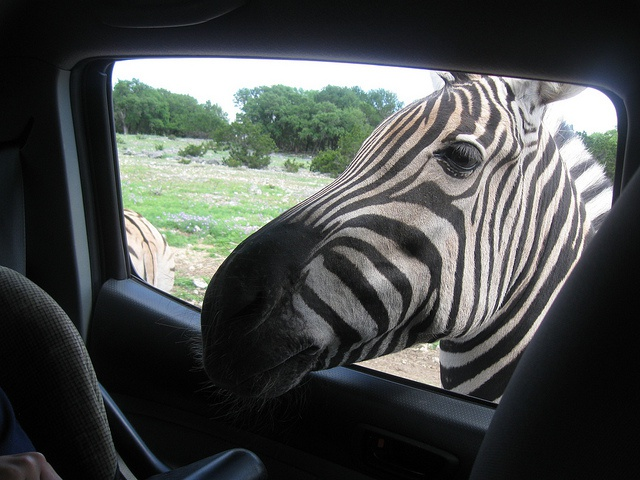Describe the objects in this image and their specific colors. I can see zebra in black, gray, lightgray, and darkgray tones and zebra in black, white, darkgray, tan, and gray tones in this image. 